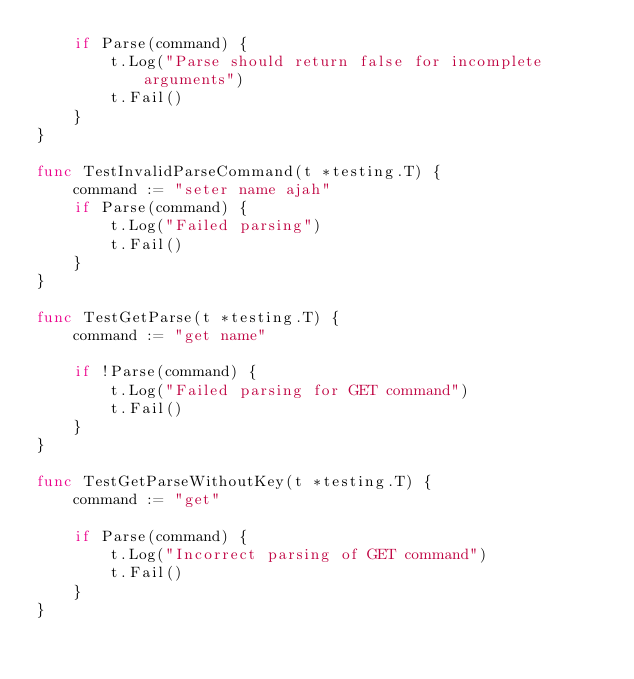Convert code to text. <code><loc_0><loc_0><loc_500><loc_500><_Go_>	if Parse(command) {
		t.Log("Parse should return false for incomplete arguments")
		t.Fail()
	}
}

func TestInvalidParseCommand(t *testing.T) {
	command := "seter name ajah"
	if Parse(command) {
		t.Log("Failed parsing")
		t.Fail()
	}
}

func TestGetParse(t *testing.T) {
	command := "get name"

	if !Parse(command) {
		t.Log("Failed parsing for GET command")
		t.Fail()
	}
}

func TestGetParseWithoutKey(t *testing.T) {
	command := "get"

	if Parse(command) {
		t.Log("Incorrect parsing of GET command")
		t.Fail()
	}
}
</code> 